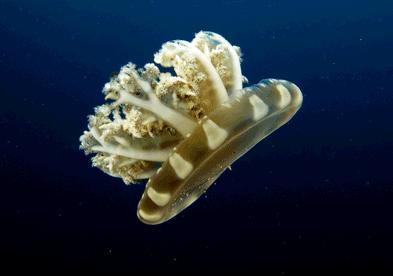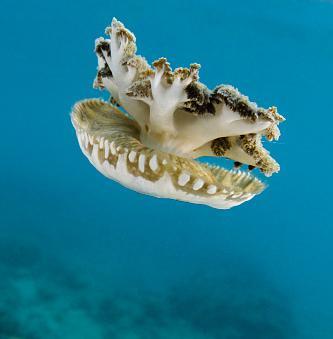The first image is the image on the left, the second image is the image on the right. For the images shown, is this caption "The jellyfish in the image on the right is pink." true? Answer yes or no. No. 